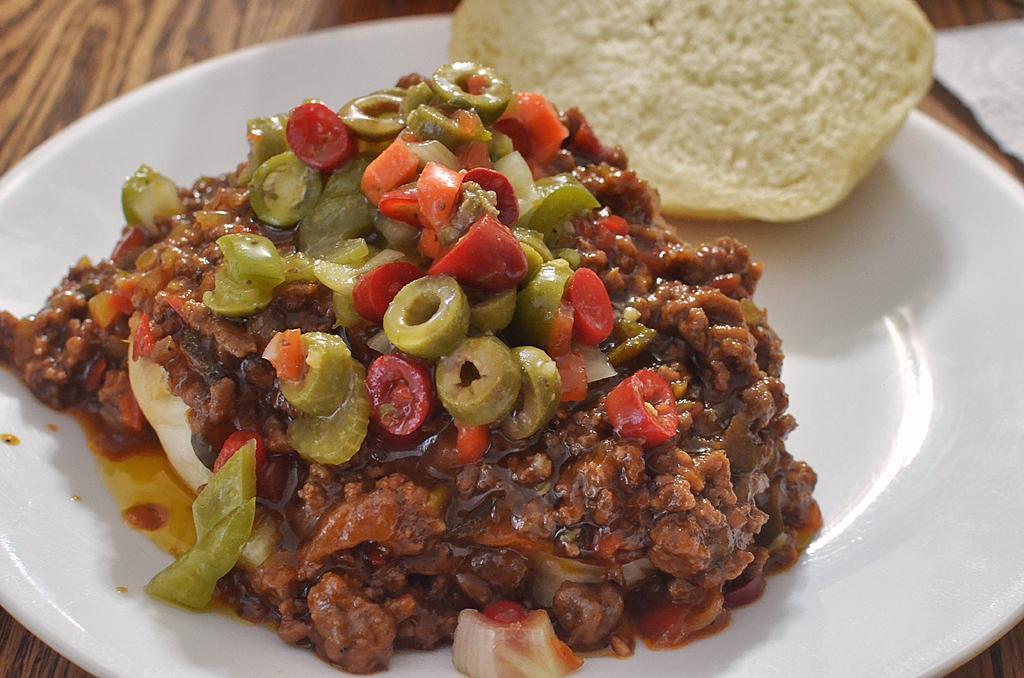Please provide a concise description of this image. In this picture there is a plate in the center of the image, which contains food items in it. 